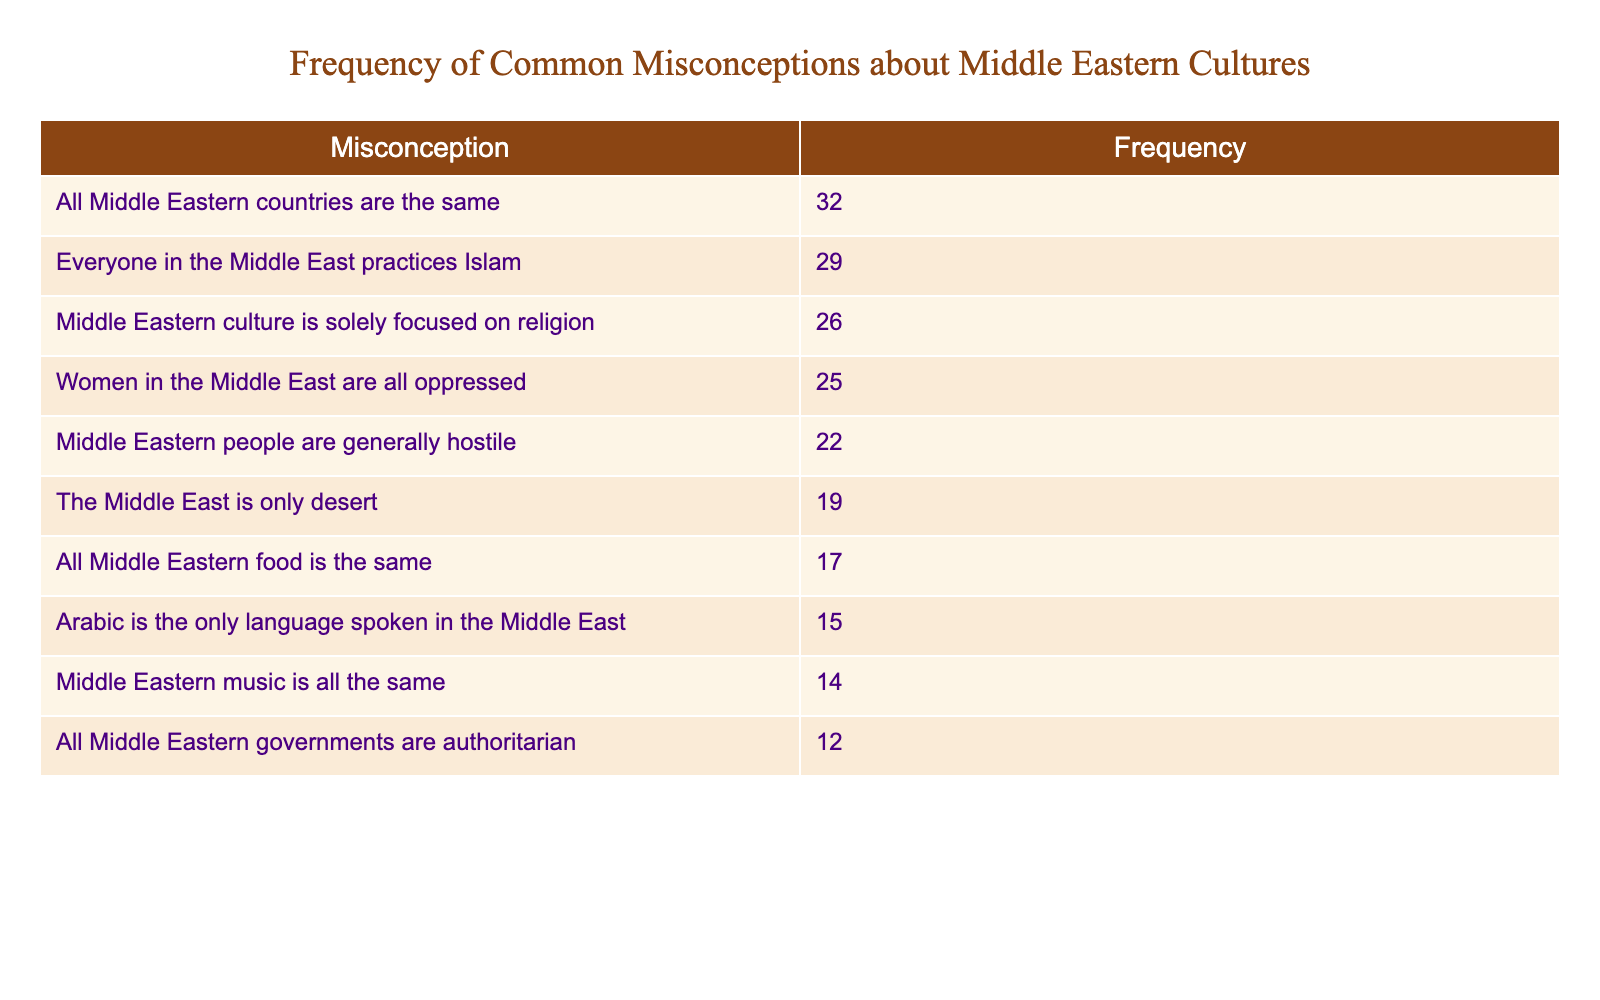What is the most common misconception about Middle Eastern cultures according to the table? The table lists different misconceptions along with their frequencies, and the highest frequency is associated with the misconception "All Middle Eastern countries are the same," which has a frequency of 32.
Answer: 32 How many misconceptions have a frequency greater than 20? Looking through the table, there are five misconceptions with a frequency greater than 20: "All Middle Eastern countries are the same" (32), "Everyone in the Middle East practices Islam" (29), "Middle Eastern culture is solely focused on religion" (26), "Women in the Middle East are all oppressed" (25), and "Middle Eastern people are generally hostile" (22). Therefore, the count is 5.
Answer: 5 What is the difference in frequency between the most and least common misconceptions? The most common misconception is "All Middle Eastern countries are the same" with a frequency of 32, and the least common misconception is "All Middle Eastern governments are authoritarian" with a frequency of 12. The difference is calculated as 32 - 12 = 20.
Answer: 20 Is it true that the misconception "Arabic is the only language spoken in the Middle East" has a frequency higher than 15? The frequency for "Arabic is the only language spoken in the Middle East" is 15. Thus, it is false to say it has a frequency higher than 15.
Answer: No What is the total frequency of misconceptions related to culture and religion? The misconceptions that involve culture and religion are "Everyone in the Middle East practices Islam" (29), "Middle Eastern culture is solely focused on religion" (26), and "Women in the Middle East are all oppressed" (25). Adding these frequencies gives: 29 + 26 + 25 = 80.
Answer: 80 How many misconceptions are related to food or music? The misconceptions that pertain to food or music are "All Middle Eastern food is the same" (17) and "Middle Eastern music is all the same" (14). There are 2 misconceptions in total.
Answer: 2 Which misconception has a frequency lower than 15? The only misconception with a frequency lower than 15 on the list is "All Middle Eastern governments are authoritarian," which has a frequency of 12.
Answer: 12 What percentage of misconceptions are about women in the Middle East? There are three misconceptions related to women: "Women in the Middle East are all oppressed" (25), out of a total of 10 misconceptions. The percentage is calculated as (1/10) * 100 = 10%.
Answer: 10% 